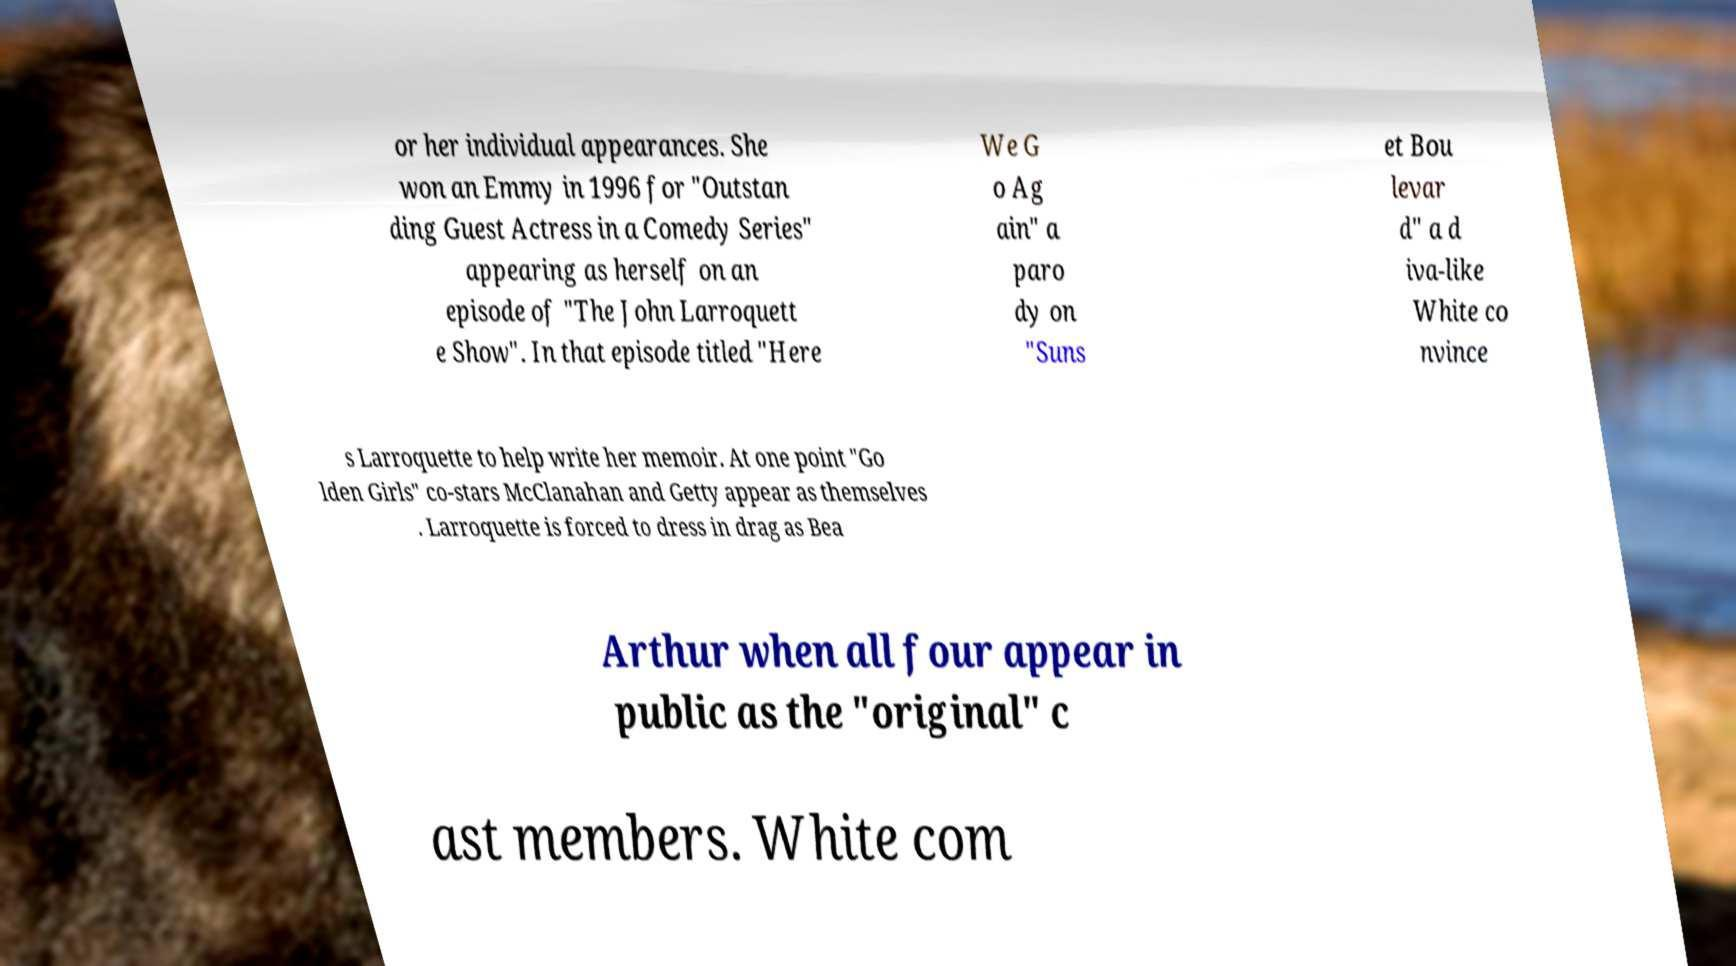Could you extract and type out the text from this image? or her individual appearances. She won an Emmy in 1996 for "Outstan ding Guest Actress in a Comedy Series" appearing as herself on an episode of "The John Larroquett e Show". In that episode titled "Here We G o Ag ain" a paro dy on "Suns et Bou levar d" a d iva-like White co nvince s Larroquette to help write her memoir. At one point "Go lden Girls" co-stars McClanahan and Getty appear as themselves . Larroquette is forced to dress in drag as Bea Arthur when all four appear in public as the "original" c ast members. White com 